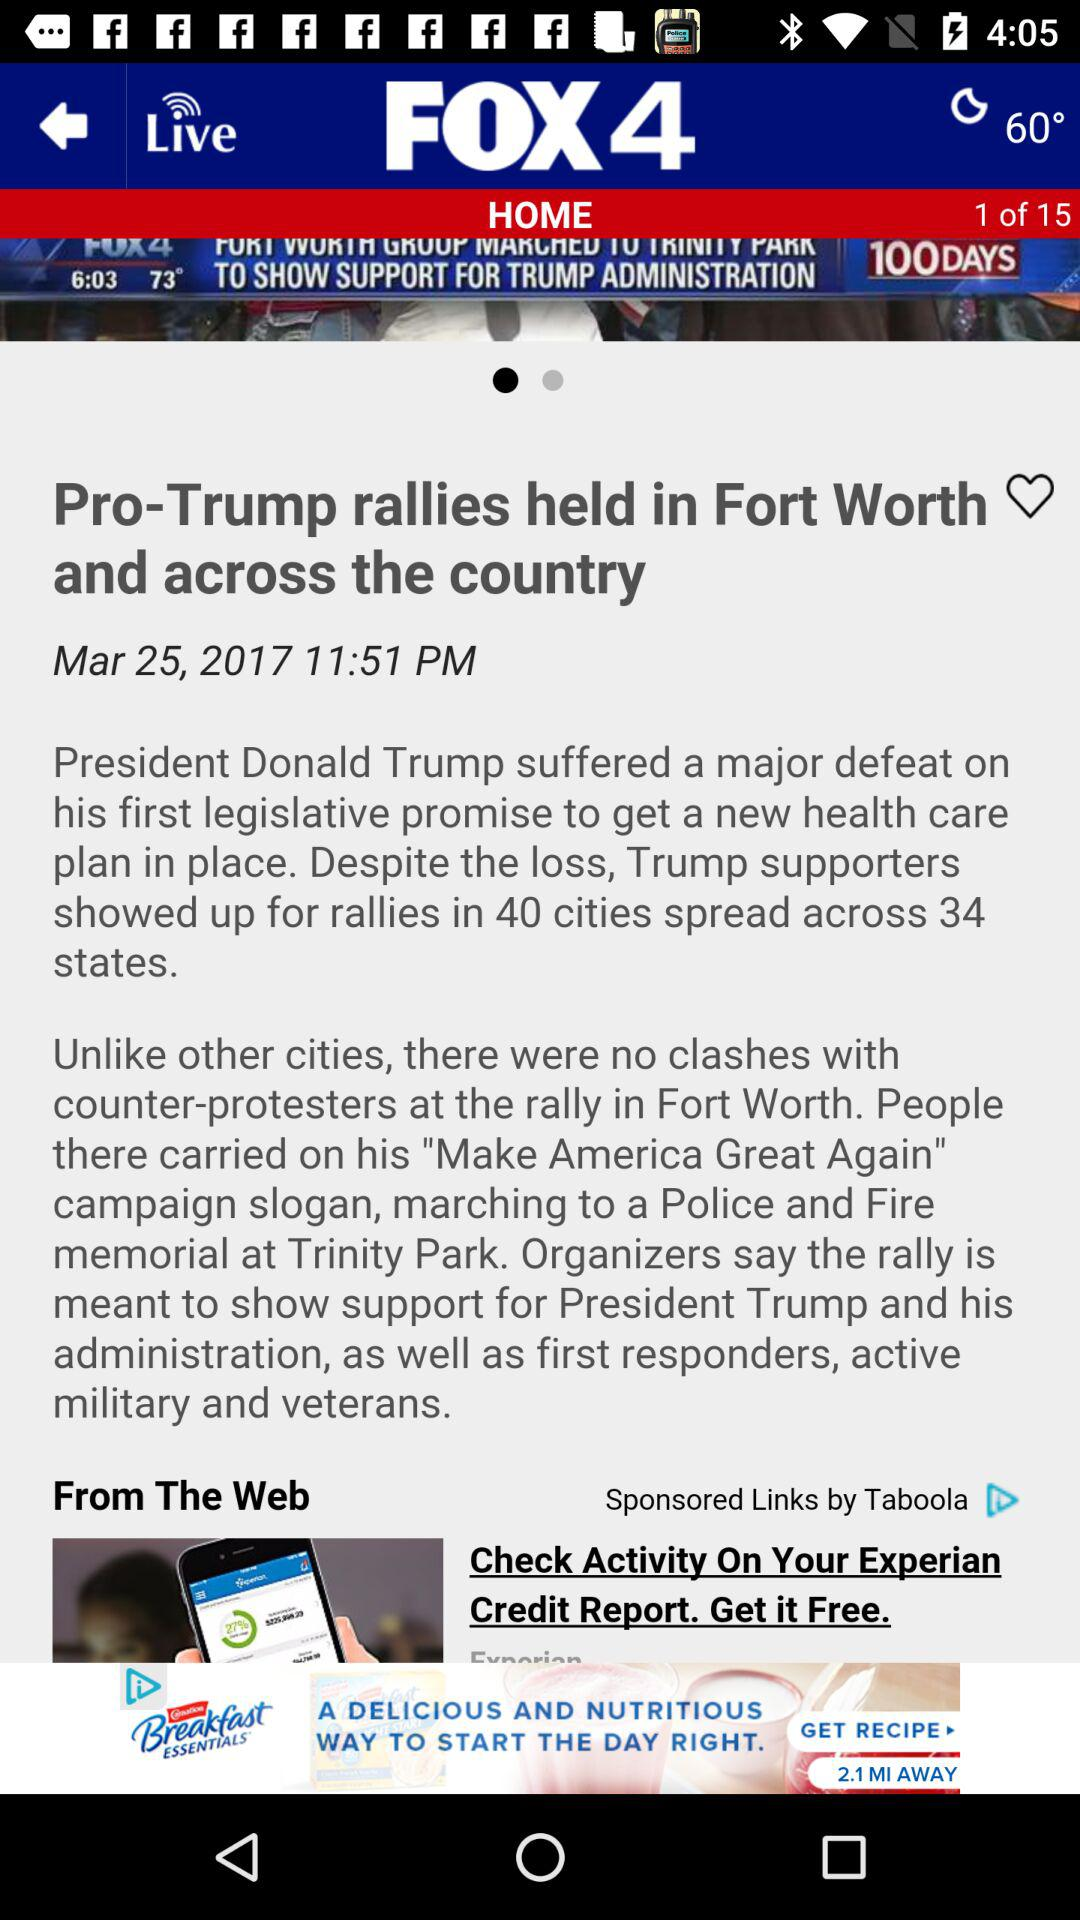What is the article's publication date? The article's publication date is March 25, 2017. 